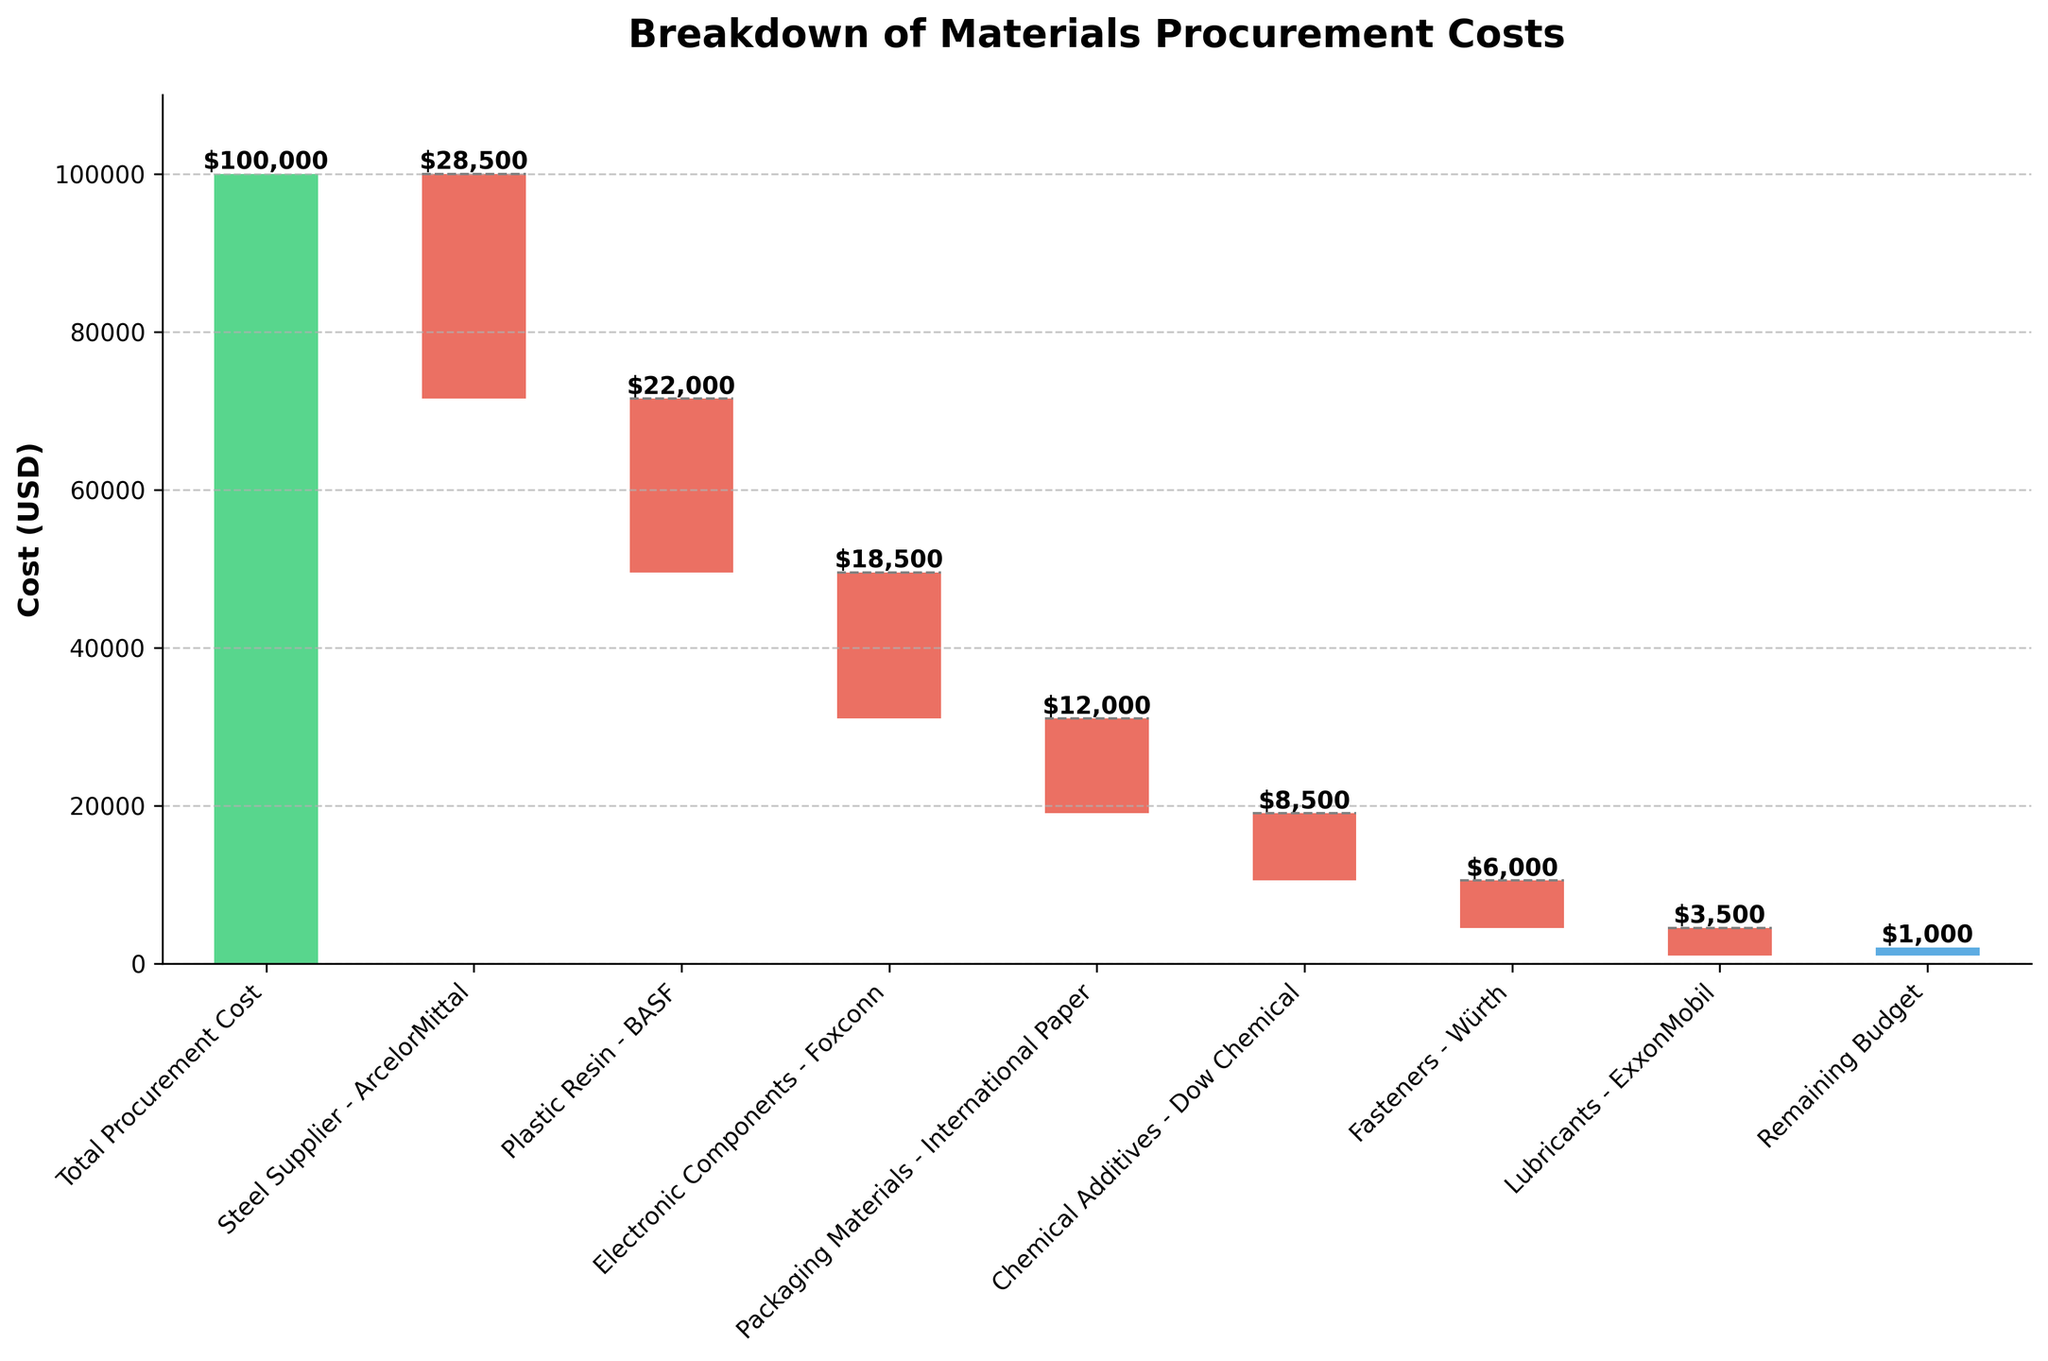What is the total procurement cost indicated in the chart? The chart title mentions that it is showing the breakdown of the total procurement cost, which is displayed as the starting point.
Answer: $100,000 How much did we spend on steel from ArcelorMittal? The bar labeled "Steel Supplier - ArcelorMittal" shows a downward value starting from the total procurement cost.
Answer: $28,500 Which vendor had the lowest procurement cost and what is the amount? Lubricants from ExxonMobil has the smallest downward bar, indicating the lowest procurement cost.
Answer: $3,500 How much remaining budget do we have after all procurements? The final bar in the waterfall chart, labeled "Remaining Budget," indicates the remaining budget.
Answer: $1,000 What is the cumulative procurement cost for electronic components from Foxconn and fasteners from Würth? Adding the costs of electronic components (-$18,500) and fasteners (-$6,000) together gives the cumulative procurement cost.
Answer: $24,500 How does the procurement cost for plastic resin from BASF compare to packaging materials from International Paper? Comparing the lengths of the downward bars, plastic resin (-$22,000) is greater than packaging materials (-$12,000).
Answer: Higher by $10,000 What is the total expenditure for materials from BASF and Dow Chemical? Summing the expenditures for plastic resin from BASF (-$22,000) and chemical additives from Dow Chemical (-$8,500) gives the total.
Answer: $30,500 By how much does the procurement cost for steel exceed that for electronic components? The cost for steel from ArcelorMittal is -$28,500 and for electronic components from Foxconn is -$18,500. Subtracting these gives the difference.
Answer: $10,000 What is the second highest procurement cost and which material does it correspond to? By examining the downward bars, plastic resin from BASF is the second highest procurement cost after steel.
Answer: $22,000 If the total procurement cost decreases by 10%, what will be the new total cost? Reducing the total procurement cost by 10% (100,000 * 0.10 = 10,000) and subtracting this from the original total (100,000 - 10,000) will give the new total cost.
Answer: $90,000 